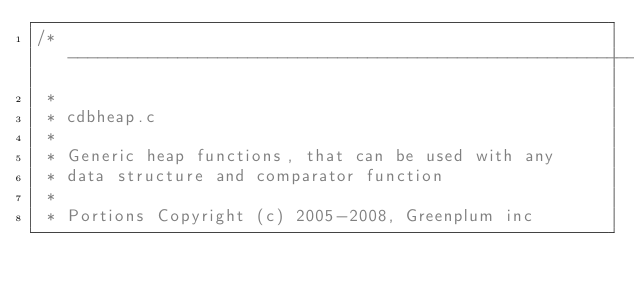<code> <loc_0><loc_0><loc_500><loc_500><_C_>/*-------------------------------------------------------------------------
 *
 * cdbheap.c
 *
 * Generic heap functions, that can be used with any
 * data structure and comparator function
 *
 * Portions Copyright (c) 2005-2008, Greenplum inc</code> 